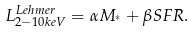Convert formula to latex. <formula><loc_0><loc_0><loc_500><loc_500>L _ { 2 - 1 0 k e V } ^ { L e h m e r } = \alpha M _ { ^ { * } } + \beta S F R .</formula> 